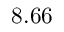<formula> <loc_0><loc_0><loc_500><loc_500>8 . 6 6</formula> 